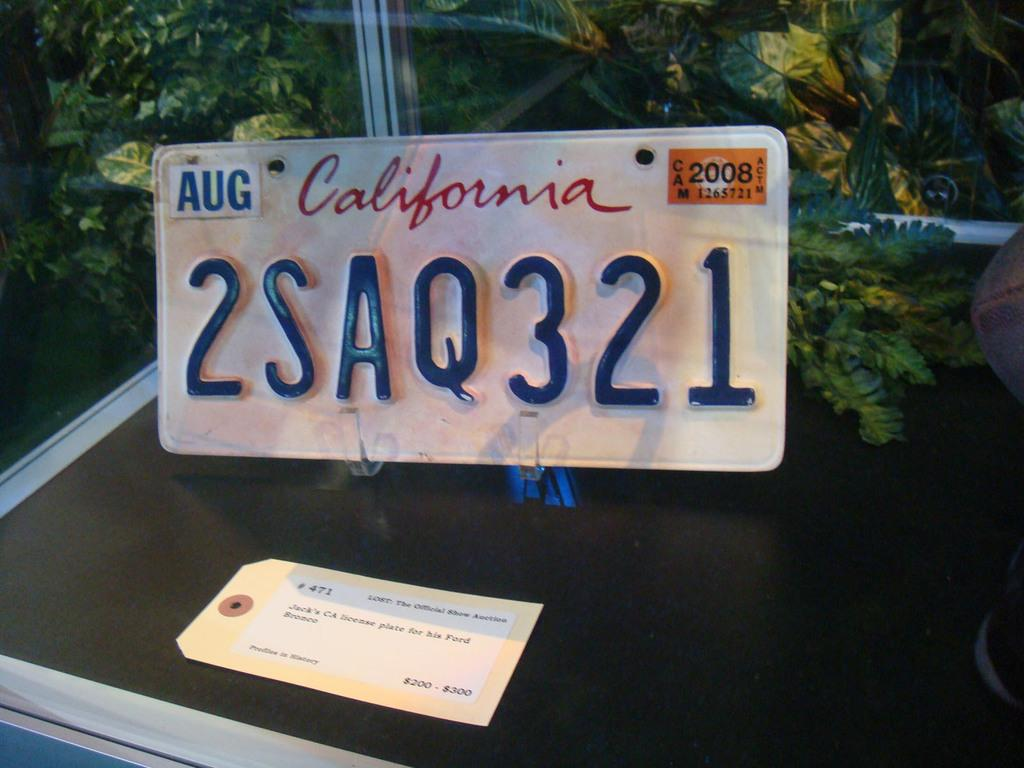What is the main subject of the image? The main subject of the image is a number plate of a vehicle. Is there any additional information about the number plate? Yes, the number plate has a price tag. What can be seen in the background of the image? There are trees visible behind the number plate. What type of oil is being used in the protest depicted in the image? There is no protest or oil present in the image; it features a number plate with a price tag and trees in the background. 